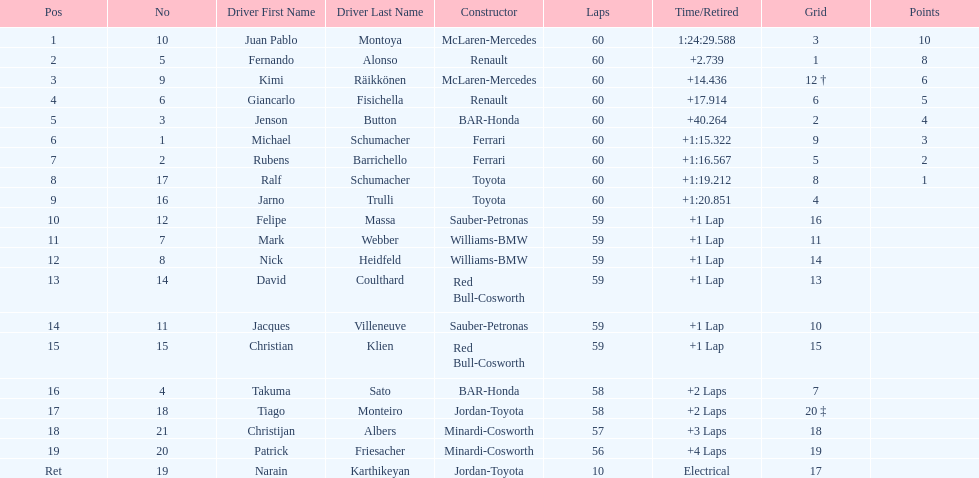Which driver has the least amount of points? Ralf Schumacher. 